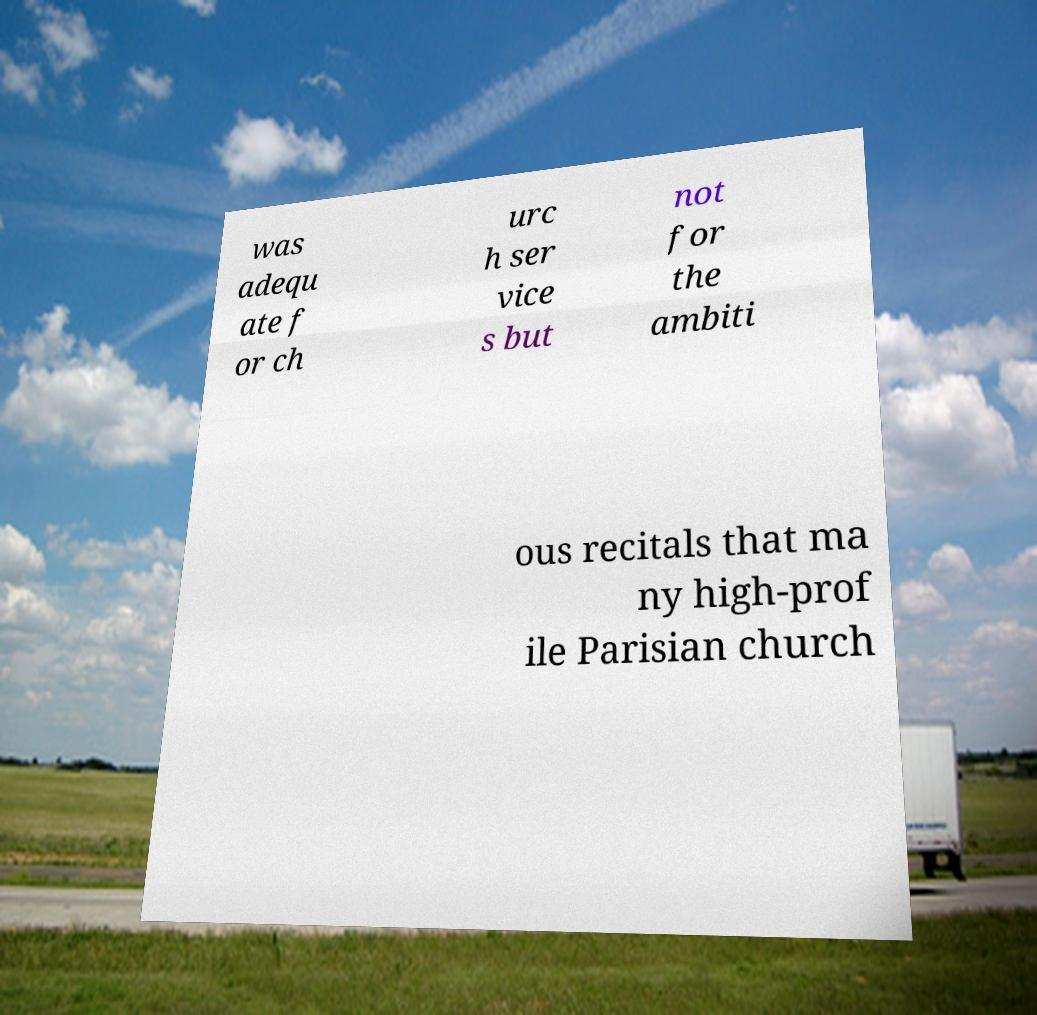What messages or text are displayed in this image? I need them in a readable, typed format. was adequ ate f or ch urc h ser vice s but not for the ambiti ous recitals that ma ny high-prof ile Parisian church 